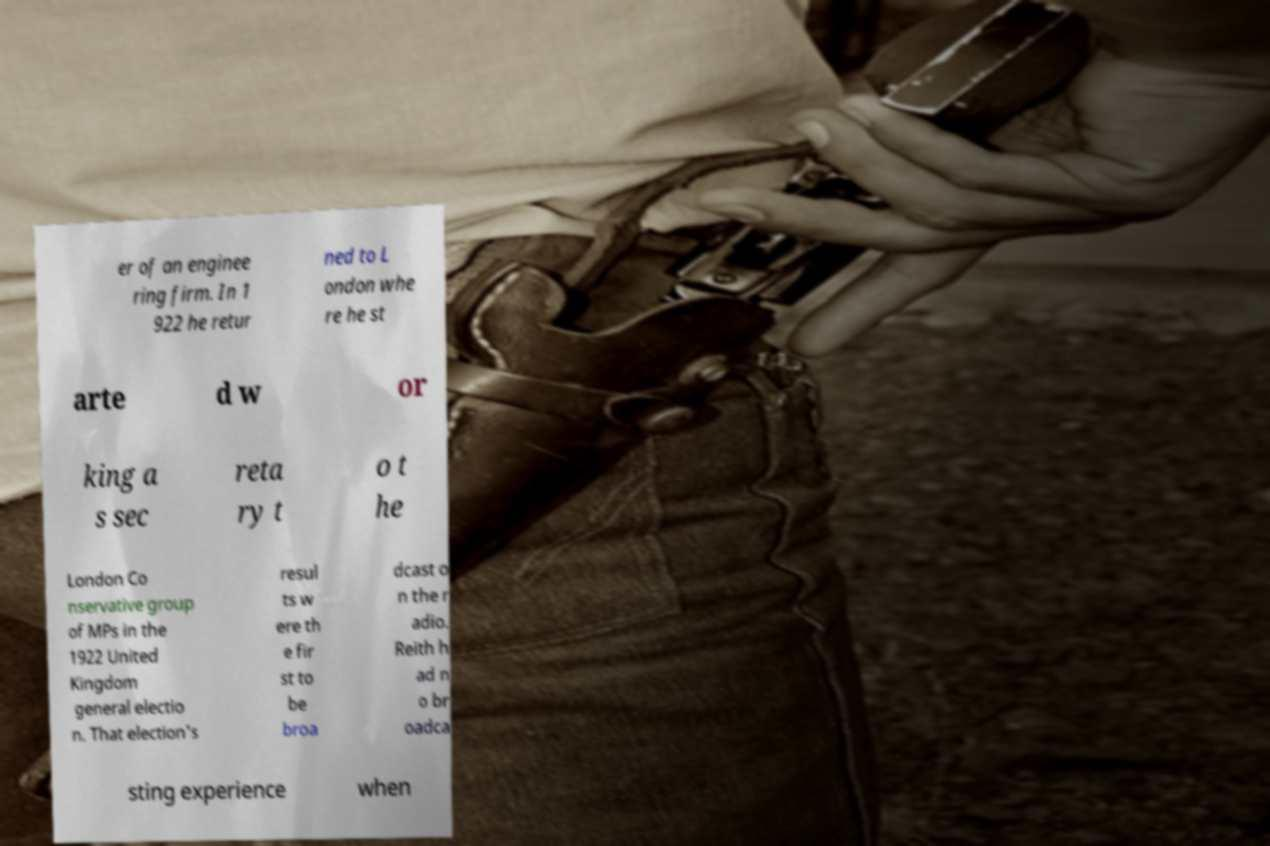What messages or text are displayed in this image? I need them in a readable, typed format. er of an enginee ring firm. In 1 922 he retur ned to L ondon whe re he st arte d w or king a s sec reta ry t o t he London Co nservative group of MPs in the 1922 United Kingdom general electio n. That election's resul ts w ere th e fir st to be broa dcast o n the r adio. Reith h ad n o br oadca sting experience when 